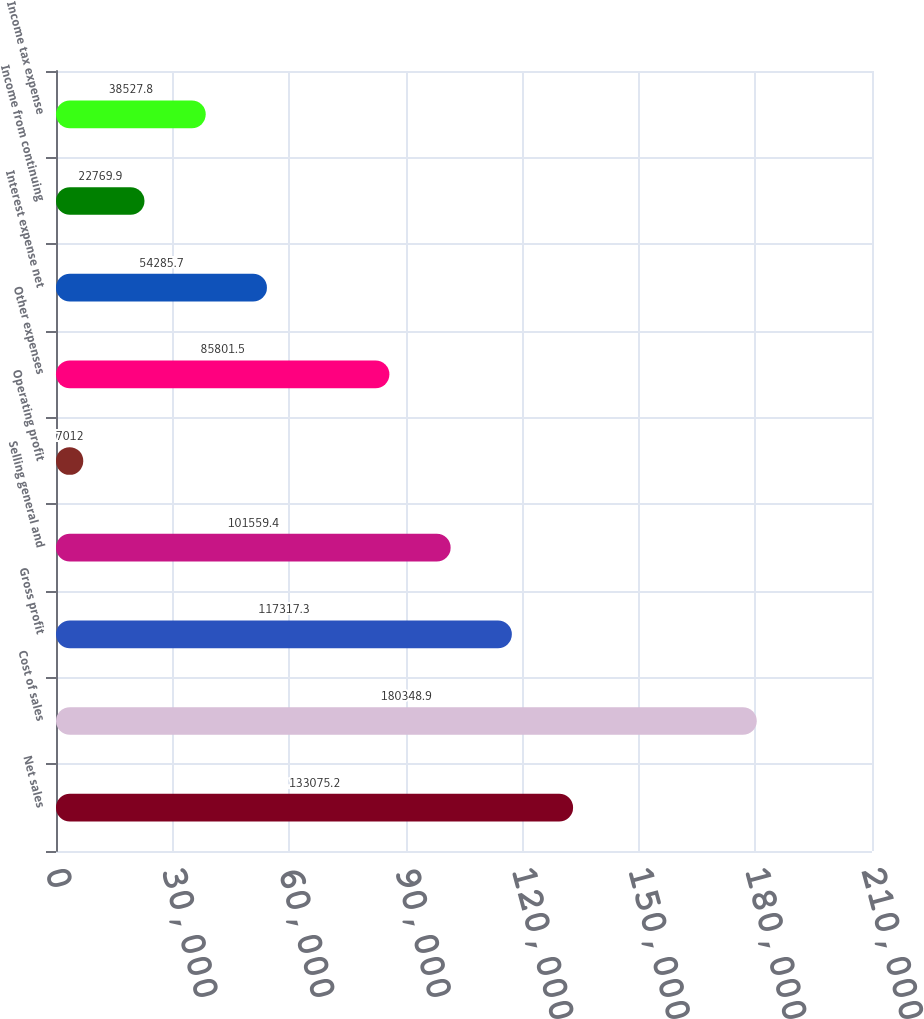Convert chart to OTSL. <chart><loc_0><loc_0><loc_500><loc_500><bar_chart><fcel>Net sales<fcel>Cost of sales<fcel>Gross profit<fcel>Selling general and<fcel>Operating profit<fcel>Other expenses<fcel>Interest expense net<fcel>Income from continuing<fcel>Income tax expense<nl><fcel>133075<fcel>180349<fcel>117317<fcel>101559<fcel>7012<fcel>85801.5<fcel>54285.7<fcel>22769.9<fcel>38527.8<nl></chart> 